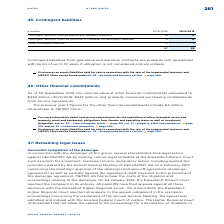According to Metro Ag's financial document, What are Contingent liabilities from guarantee and warranty contracts? primarily rent guarantees with terms of up to 10 years if utilisation is not considered entirely unlikely.. The document states: "bilities from guarantee and warranty contracts are primarily rent guarantees with terms of up to 10 years if utilisation is not considered entirely un..." Also, What are the Contingent liabilities in FY2019? According to the financial document, 30 (in millions). The relevant text states: "€ million 30/9/2018 30/9/2019..." Also, What are the components making up the Contingent liabilities in the table? The document contains multiple relevant values: Contingent liabilities from guarantee and warranty contracts, Contingent liabilities from the provision of collateral for third-party liabilities, Other contingent liabilities. From the document: "Contingent liabilities from guarantee and warranty contracts 18 17 Contingent liabilities from the provision of collateral for third-party liabilities..." Additionally, In which year were contingent liabilities larger? According to the financial document, 2019. The relevant text states: "€ million 30/9/2018 30/9/2019..." Also, can you calculate: What was the change in contingent liabilities in FY2019 from FY2018? Based on the calculation: 30-27, the result is 3 (in millions). This is based on the information: "27 30 27 30..." The key data points involved are: 27, 30. Also, can you calculate: What was the percentage change in contingent liabilities in FY2019 from FY2018? To answer this question, I need to perform calculations using the financial data. The calculation is: (30-27)/27, which equals 11.11 (percentage). This is based on the information: "27 30 27 30..." The key data points involved are: 27, 30. 